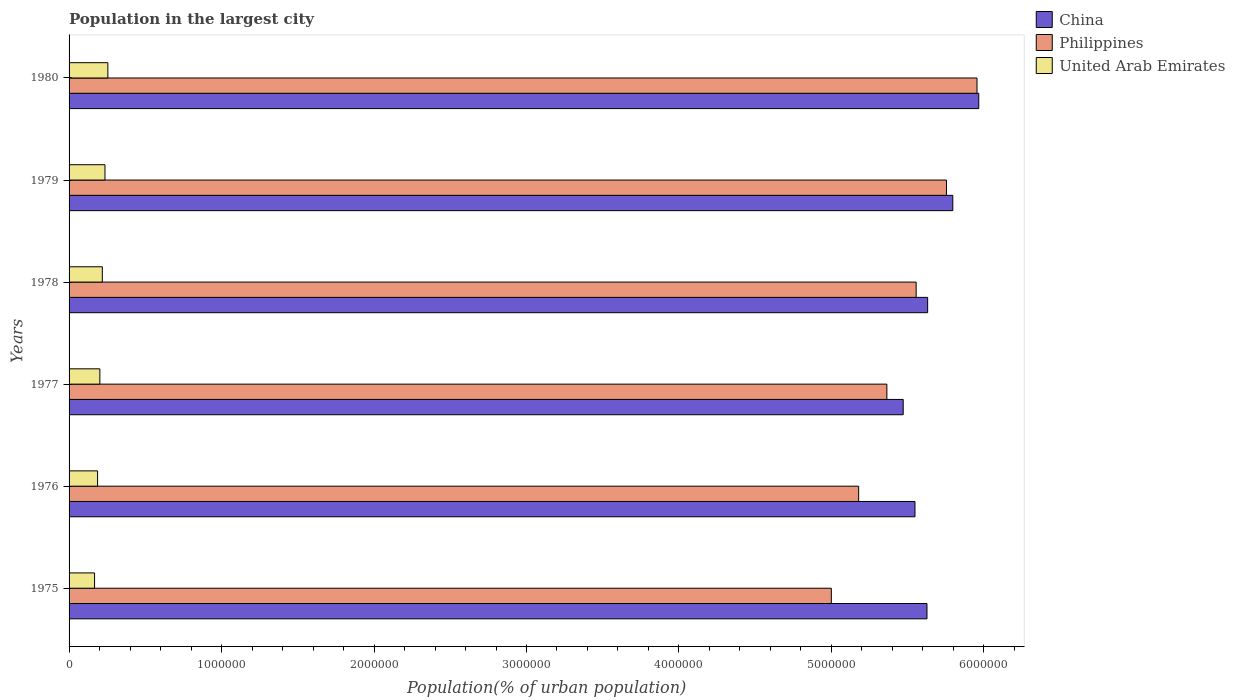How many different coloured bars are there?
Provide a succinct answer. 3. What is the label of the 2nd group of bars from the top?
Your response must be concise. 1979. What is the population in the largest city in Philippines in 1979?
Keep it short and to the point. 5.75e+06. Across all years, what is the maximum population in the largest city in Philippines?
Your response must be concise. 5.95e+06. Across all years, what is the minimum population in the largest city in China?
Your response must be concise. 5.47e+06. In which year was the population in the largest city in China maximum?
Make the answer very short. 1980. In which year was the population in the largest city in China minimum?
Keep it short and to the point. 1977. What is the total population in the largest city in Philippines in the graph?
Your answer should be very brief. 3.28e+07. What is the difference between the population in the largest city in China in 1976 and that in 1978?
Keep it short and to the point. -8.30e+04. What is the difference between the population in the largest city in Philippines in 1978 and the population in the largest city in China in 1977?
Your answer should be very brief. 8.50e+04. What is the average population in the largest city in United Arab Emirates per year?
Your response must be concise. 2.11e+05. In the year 1979, what is the difference between the population in the largest city in Philippines and population in the largest city in China?
Give a very brief answer. -4.16e+04. What is the ratio of the population in the largest city in Philippines in 1978 to that in 1980?
Provide a short and direct response. 0.93. Is the population in the largest city in China in 1977 less than that in 1978?
Keep it short and to the point. Yes. What is the difference between the highest and the second highest population in the largest city in United Arab Emirates?
Provide a short and direct response. 1.89e+04. What is the difference between the highest and the lowest population in the largest city in China?
Your answer should be compact. 4.96e+05. What does the 2nd bar from the top in 1978 represents?
Ensure brevity in your answer.  Philippines. What does the 1st bar from the bottom in 1975 represents?
Ensure brevity in your answer.  China. Is it the case that in every year, the sum of the population in the largest city in United Arab Emirates and population in the largest city in China is greater than the population in the largest city in Philippines?
Ensure brevity in your answer.  Yes. Are all the bars in the graph horizontal?
Give a very brief answer. Yes. How many years are there in the graph?
Provide a succinct answer. 6. Does the graph contain any zero values?
Keep it short and to the point. No. Does the graph contain grids?
Give a very brief answer. No. Where does the legend appear in the graph?
Offer a very short reply. Top right. What is the title of the graph?
Ensure brevity in your answer.  Population in the largest city. Does "Costa Rica" appear as one of the legend labels in the graph?
Ensure brevity in your answer.  No. What is the label or title of the X-axis?
Your answer should be compact. Population(% of urban population). What is the Population(% of urban population) in China in 1975?
Keep it short and to the point. 5.63e+06. What is the Population(% of urban population) in Philippines in 1975?
Give a very brief answer. 5.00e+06. What is the Population(% of urban population) of United Arab Emirates in 1975?
Your answer should be compact. 1.67e+05. What is the Population(% of urban population) of China in 1976?
Keep it short and to the point. 5.55e+06. What is the Population(% of urban population) in Philippines in 1976?
Offer a terse response. 5.18e+06. What is the Population(% of urban population) in United Arab Emirates in 1976?
Provide a short and direct response. 1.87e+05. What is the Population(% of urban population) in China in 1977?
Keep it short and to the point. 5.47e+06. What is the Population(% of urban population) in Philippines in 1977?
Your answer should be very brief. 5.36e+06. What is the Population(% of urban population) of United Arab Emirates in 1977?
Provide a succinct answer. 2.02e+05. What is the Population(% of urban population) in China in 1978?
Ensure brevity in your answer.  5.63e+06. What is the Population(% of urban population) in Philippines in 1978?
Ensure brevity in your answer.  5.56e+06. What is the Population(% of urban population) in United Arab Emirates in 1978?
Give a very brief answer. 2.18e+05. What is the Population(% of urban population) in China in 1979?
Give a very brief answer. 5.80e+06. What is the Population(% of urban population) of Philippines in 1979?
Offer a terse response. 5.75e+06. What is the Population(% of urban population) of United Arab Emirates in 1979?
Keep it short and to the point. 2.36e+05. What is the Population(% of urban population) of China in 1980?
Your answer should be very brief. 5.97e+06. What is the Population(% of urban population) in Philippines in 1980?
Offer a terse response. 5.95e+06. What is the Population(% of urban population) in United Arab Emirates in 1980?
Make the answer very short. 2.54e+05. Across all years, what is the maximum Population(% of urban population) of China?
Your answer should be compact. 5.97e+06. Across all years, what is the maximum Population(% of urban population) of Philippines?
Ensure brevity in your answer.  5.95e+06. Across all years, what is the maximum Population(% of urban population) in United Arab Emirates?
Give a very brief answer. 2.54e+05. Across all years, what is the minimum Population(% of urban population) of China?
Give a very brief answer. 5.47e+06. Across all years, what is the minimum Population(% of urban population) of Philippines?
Provide a succinct answer. 5.00e+06. Across all years, what is the minimum Population(% of urban population) of United Arab Emirates?
Make the answer very short. 1.67e+05. What is the total Population(% of urban population) of China in the graph?
Provide a succinct answer. 3.40e+07. What is the total Population(% of urban population) in Philippines in the graph?
Offer a terse response. 3.28e+07. What is the total Population(% of urban population) of United Arab Emirates in the graph?
Provide a succinct answer. 1.26e+06. What is the difference between the Population(% of urban population) of China in 1975 and that in 1976?
Your answer should be compact. 7.87e+04. What is the difference between the Population(% of urban population) in Philippines in 1975 and that in 1976?
Offer a terse response. -1.79e+05. What is the difference between the Population(% of urban population) of United Arab Emirates in 1975 and that in 1976?
Offer a terse response. -1.98e+04. What is the difference between the Population(% of urban population) in China in 1975 and that in 1977?
Offer a terse response. 1.56e+05. What is the difference between the Population(% of urban population) in Philippines in 1975 and that in 1977?
Make the answer very short. -3.64e+05. What is the difference between the Population(% of urban population) in United Arab Emirates in 1975 and that in 1977?
Your response must be concise. -3.47e+04. What is the difference between the Population(% of urban population) of China in 1975 and that in 1978?
Give a very brief answer. -4324. What is the difference between the Population(% of urban population) of Philippines in 1975 and that in 1978?
Give a very brief answer. -5.56e+05. What is the difference between the Population(% of urban population) of United Arab Emirates in 1975 and that in 1978?
Provide a succinct answer. -5.09e+04. What is the difference between the Population(% of urban population) in China in 1975 and that in 1979?
Your answer should be very brief. -1.69e+05. What is the difference between the Population(% of urban population) in Philippines in 1975 and that in 1979?
Ensure brevity in your answer.  -7.55e+05. What is the difference between the Population(% of urban population) of United Arab Emirates in 1975 and that in 1979?
Provide a short and direct response. -6.83e+04. What is the difference between the Population(% of urban population) of China in 1975 and that in 1980?
Ensure brevity in your answer.  -3.40e+05. What is the difference between the Population(% of urban population) in Philippines in 1975 and that in 1980?
Ensure brevity in your answer.  -9.55e+05. What is the difference between the Population(% of urban population) in United Arab Emirates in 1975 and that in 1980?
Offer a terse response. -8.72e+04. What is the difference between the Population(% of urban population) in China in 1976 and that in 1977?
Your answer should be very brief. 7.74e+04. What is the difference between the Population(% of urban population) in Philippines in 1976 and that in 1977?
Offer a very short reply. -1.85e+05. What is the difference between the Population(% of urban population) of United Arab Emirates in 1976 and that in 1977?
Make the answer very short. -1.49e+04. What is the difference between the Population(% of urban population) in China in 1976 and that in 1978?
Offer a very short reply. -8.30e+04. What is the difference between the Population(% of urban population) of Philippines in 1976 and that in 1978?
Offer a very short reply. -3.77e+05. What is the difference between the Population(% of urban population) in United Arab Emirates in 1976 and that in 1978?
Provide a succinct answer. -3.11e+04. What is the difference between the Population(% of urban population) in China in 1976 and that in 1979?
Ensure brevity in your answer.  -2.48e+05. What is the difference between the Population(% of urban population) in Philippines in 1976 and that in 1979?
Keep it short and to the point. -5.76e+05. What is the difference between the Population(% of urban population) of United Arab Emirates in 1976 and that in 1979?
Give a very brief answer. -4.85e+04. What is the difference between the Population(% of urban population) in China in 1976 and that in 1980?
Offer a terse response. -4.18e+05. What is the difference between the Population(% of urban population) in Philippines in 1976 and that in 1980?
Ensure brevity in your answer.  -7.76e+05. What is the difference between the Population(% of urban population) in United Arab Emirates in 1976 and that in 1980?
Offer a very short reply. -6.74e+04. What is the difference between the Population(% of urban population) of China in 1977 and that in 1978?
Ensure brevity in your answer.  -1.60e+05. What is the difference between the Population(% of urban population) of Philippines in 1977 and that in 1978?
Ensure brevity in your answer.  -1.92e+05. What is the difference between the Population(% of urban population) in United Arab Emirates in 1977 and that in 1978?
Offer a very short reply. -1.61e+04. What is the difference between the Population(% of urban population) in China in 1977 and that in 1979?
Your answer should be very brief. -3.25e+05. What is the difference between the Population(% of urban population) in Philippines in 1977 and that in 1979?
Offer a very short reply. -3.91e+05. What is the difference between the Population(% of urban population) in United Arab Emirates in 1977 and that in 1979?
Your answer should be compact. -3.36e+04. What is the difference between the Population(% of urban population) of China in 1977 and that in 1980?
Provide a short and direct response. -4.96e+05. What is the difference between the Population(% of urban population) of Philippines in 1977 and that in 1980?
Your response must be concise. -5.91e+05. What is the difference between the Population(% of urban population) of United Arab Emirates in 1977 and that in 1980?
Provide a succinct answer. -5.24e+04. What is the difference between the Population(% of urban population) of China in 1978 and that in 1979?
Provide a short and direct response. -1.65e+05. What is the difference between the Population(% of urban population) of Philippines in 1978 and that in 1979?
Offer a very short reply. -1.99e+05. What is the difference between the Population(% of urban population) of United Arab Emirates in 1978 and that in 1979?
Your answer should be very brief. -1.74e+04. What is the difference between the Population(% of urban population) in China in 1978 and that in 1980?
Make the answer very short. -3.35e+05. What is the difference between the Population(% of urban population) of Philippines in 1978 and that in 1980?
Keep it short and to the point. -3.99e+05. What is the difference between the Population(% of urban population) in United Arab Emirates in 1978 and that in 1980?
Keep it short and to the point. -3.63e+04. What is the difference between the Population(% of urban population) of China in 1979 and that in 1980?
Ensure brevity in your answer.  -1.70e+05. What is the difference between the Population(% of urban population) in Philippines in 1979 and that in 1980?
Provide a succinct answer. -2.00e+05. What is the difference between the Population(% of urban population) in United Arab Emirates in 1979 and that in 1980?
Provide a short and direct response. -1.89e+04. What is the difference between the Population(% of urban population) of China in 1975 and the Population(% of urban population) of Philippines in 1976?
Your answer should be compact. 4.48e+05. What is the difference between the Population(% of urban population) of China in 1975 and the Population(% of urban population) of United Arab Emirates in 1976?
Your answer should be very brief. 5.44e+06. What is the difference between the Population(% of urban population) of Philippines in 1975 and the Population(% of urban population) of United Arab Emirates in 1976?
Provide a short and direct response. 4.81e+06. What is the difference between the Population(% of urban population) in China in 1975 and the Population(% of urban population) in Philippines in 1977?
Your answer should be compact. 2.63e+05. What is the difference between the Population(% of urban population) of China in 1975 and the Population(% of urban population) of United Arab Emirates in 1977?
Ensure brevity in your answer.  5.42e+06. What is the difference between the Population(% of urban population) of Philippines in 1975 and the Population(% of urban population) of United Arab Emirates in 1977?
Offer a very short reply. 4.80e+06. What is the difference between the Population(% of urban population) of China in 1975 and the Population(% of urban population) of Philippines in 1978?
Your response must be concise. 7.10e+04. What is the difference between the Population(% of urban population) in China in 1975 and the Population(% of urban population) in United Arab Emirates in 1978?
Make the answer very short. 5.41e+06. What is the difference between the Population(% of urban population) in Philippines in 1975 and the Population(% of urban population) in United Arab Emirates in 1978?
Give a very brief answer. 4.78e+06. What is the difference between the Population(% of urban population) in China in 1975 and the Population(% of urban population) in Philippines in 1979?
Offer a terse response. -1.28e+05. What is the difference between the Population(% of urban population) of China in 1975 and the Population(% of urban population) of United Arab Emirates in 1979?
Your response must be concise. 5.39e+06. What is the difference between the Population(% of urban population) in Philippines in 1975 and the Population(% of urban population) in United Arab Emirates in 1979?
Your answer should be very brief. 4.76e+06. What is the difference between the Population(% of urban population) in China in 1975 and the Population(% of urban population) in Philippines in 1980?
Your answer should be very brief. -3.28e+05. What is the difference between the Population(% of urban population) in China in 1975 and the Population(% of urban population) in United Arab Emirates in 1980?
Your answer should be compact. 5.37e+06. What is the difference between the Population(% of urban population) of Philippines in 1975 and the Population(% of urban population) of United Arab Emirates in 1980?
Offer a terse response. 4.74e+06. What is the difference between the Population(% of urban population) of China in 1976 and the Population(% of urban population) of Philippines in 1977?
Give a very brief answer. 1.84e+05. What is the difference between the Population(% of urban population) in China in 1976 and the Population(% of urban population) in United Arab Emirates in 1977?
Your response must be concise. 5.35e+06. What is the difference between the Population(% of urban population) in Philippines in 1976 and the Population(% of urban population) in United Arab Emirates in 1977?
Your answer should be very brief. 4.98e+06. What is the difference between the Population(% of urban population) in China in 1976 and the Population(% of urban population) in Philippines in 1978?
Provide a short and direct response. -7629. What is the difference between the Population(% of urban population) of China in 1976 and the Population(% of urban population) of United Arab Emirates in 1978?
Ensure brevity in your answer.  5.33e+06. What is the difference between the Population(% of urban population) in Philippines in 1976 and the Population(% of urban population) in United Arab Emirates in 1978?
Your answer should be very brief. 4.96e+06. What is the difference between the Population(% of urban population) of China in 1976 and the Population(% of urban population) of Philippines in 1979?
Offer a terse response. -2.06e+05. What is the difference between the Population(% of urban population) in China in 1976 and the Population(% of urban population) in United Arab Emirates in 1979?
Provide a short and direct response. 5.31e+06. What is the difference between the Population(% of urban population) in Philippines in 1976 and the Population(% of urban population) in United Arab Emirates in 1979?
Provide a succinct answer. 4.94e+06. What is the difference between the Population(% of urban population) of China in 1976 and the Population(% of urban population) of Philippines in 1980?
Give a very brief answer. -4.07e+05. What is the difference between the Population(% of urban population) in China in 1976 and the Population(% of urban population) in United Arab Emirates in 1980?
Ensure brevity in your answer.  5.29e+06. What is the difference between the Population(% of urban population) of Philippines in 1976 and the Population(% of urban population) of United Arab Emirates in 1980?
Make the answer very short. 4.92e+06. What is the difference between the Population(% of urban population) in China in 1977 and the Population(% of urban population) in Philippines in 1978?
Keep it short and to the point. -8.50e+04. What is the difference between the Population(% of urban population) in China in 1977 and the Population(% of urban population) in United Arab Emirates in 1978?
Provide a short and direct response. 5.25e+06. What is the difference between the Population(% of urban population) of Philippines in 1977 and the Population(% of urban population) of United Arab Emirates in 1978?
Your response must be concise. 5.15e+06. What is the difference between the Population(% of urban population) in China in 1977 and the Population(% of urban population) in Philippines in 1979?
Offer a terse response. -2.84e+05. What is the difference between the Population(% of urban population) in China in 1977 and the Population(% of urban population) in United Arab Emirates in 1979?
Your answer should be very brief. 5.24e+06. What is the difference between the Population(% of urban population) in Philippines in 1977 and the Population(% of urban population) in United Arab Emirates in 1979?
Offer a very short reply. 5.13e+06. What is the difference between the Population(% of urban population) in China in 1977 and the Population(% of urban population) in Philippines in 1980?
Provide a succinct answer. -4.84e+05. What is the difference between the Population(% of urban population) of China in 1977 and the Population(% of urban population) of United Arab Emirates in 1980?
Provide a short and direct response. 5.22e+06. What is the difference between the Population(% of urban population) of Philippines in 1977 and the Population(% of urban population) of United Arab Emirates in 1980?
Offer a very short reply. 5.11e+06. What is the difference between the Population(% of urban population) in China in 1978 and the Population(% of urban population) in Philippines in 1979?
Give a very brief answer. -1.23e+05. What is the difference between the Population(% of urban population) in China in 1978 and the Population(% of urban population) in United Arab Emirates in 1979?
Give a very brief answer. 5.40e+06. What is the difference between the Population(% of urban population) of Philippines in 1978 and the Population(% of urban population) of United Arab Emirates in 1979?
Your response must be concise. 5.32e+06. What is the difference between the Population(% of urban population) in China in 1978 and the Population(% of urban population) in Philippines in 1980?
Your response must be concise. -3.24e+05. What is the difference between the Population(% of urban population) in China in 1978 and the Population(% of urban population) in United Arab Emirates in 1980?
Provide a succinct answer. 5.38e+06. What is the difference between the Population(% of urban population) in Philippines in 1978 and the Population(% of urban population) in United Arab Emirates in 1980?
Make the answer very short. 5.30e+06. What is the difference between the Population(% of urban population) of China in 1979 and the Population(% of urban population) of Philippines in 1980?
Offer a terse response. -1.59e+05. What is the difference between the Population(% of urban population) in China in 1979 and the Population(% of urban population) in United Arab Emirates in 1980?
Keep it short and to the point. 5.54e+06. What is the difference between the Population(% of urban population) in Philippines in 1979 and the Population(% of urban population) in United Arab Emirates in 1980?
Provide a succinct answer. 5.50e+06. What is the average Population(% of urban population) of China per year?
Ensure brevity in your answer.  5.67e+06. What is the average Population(% of urban population) in Philippines per year?
Ensure brevity in your answer.  5.47e+06. What is the average Population(% of urban population) of United Arab Emirates per year?
Make the answer very short. 2.11e+05. In the year 1975, what is the difference between the Population(% of urban population) in China and Population(% of urban population) in Philippines?
Your response must be concise. 6.27e+05. In the year 1975, what is the difference between the Population(% of urban population) of China and Population(% of urban population) of United Arab Emirates?
Make the answer very short. 5.46e+06. In the year 1975, what is the difference between the Population(% of urban population) of Philippines and Population(% of urban population) of United Arab Emirates?
Ensure brevity in your answer.  4.83e+06. In the year 1976, what is the difference between the Population(% of urban population) of China and Population(% of urban population) of Philippines?
Your response must be concise. 3.69e+05. In the year 1976, what is the difference between the Population(% of urban population) in China and Population(% of urban population) in United Arab Emirates?
Provide a short and direct response. 5.36e+06. In the year 1976, what is the difference between the Population(% of urban population) in Philippines and Population(% of urban population) in United Arab Emirates?
Ensure brevity in your answer.  4.99e+06. In the year 1977, what is the difference between the Population(% of urban population) in China and Population(% of urban population) in Philippines?
Provide a succinct answer. 1.07e+05. In the year 1977, what is the difference between the Population(% of urban population) in China and Population(% of urban population) in United Arab Emirates?
Keep it short and to the point. 5.27e+06. In the year 1977, what is the difference between the Population(% of urban population) of Philippines and Population(% of urban population) of United Arab Emirates?
Make the answer very short. 5.16e+06. In the year 1978, what is the difference between the Population(% of urban population) in China and Population(% of urban population) in Philippines?
Make the answer very short. 7.54e+04. In the year 1978, what is the difference between the Population(% of urban population) in China and Population(% of urban population) in United Arab Emirates?
Provide a succinct answer. 5.41e+06. In the year 1978, what is the difference between the Population(% of urban population) in Philippines and Population(% of urban population) in United Arab Emirates?
Offer a terse response. 5.34e+06. In the year 1979, what is the difference between the Population(% of urban population) of China and Population(% of urban population) of Philippines?
Keep it short and to the point. 4.16e+04. In the year 1979, what is the difference between the Population(% of urban population) of China and Population(% of urban population) of United Arab Emirates?
Ensure brevity in your answer.  5.56e+06. In the year 1979, what is the difference between the Population(% of urban population) of Philippines and Population(% of urban population) of United Arab Emirates?
Offer a terse response. 5.52e+06. In the year 1980, what is the difference between the Population(% of urban population) of China and Population(% of urban population) of Philippines?
Ensure brevity in your answer.  1.15e+04. In the year 1980, what is the difference between the Population(% of urban population) in China and Population(% of urban population) in United Arab Emirates?
Provide a short and direct response. 5.71e+06. In the year 1980, what is the difference between the Population(% of urban population) of Philippines and Population(% of urban population) of United Arab Emirates?
Your answer should be very brief. 5.70e+06. What is the ratio of the Population(% of urban population) of China in 1975 to that in 1976?
Provide a succinct answer. 1.01. What is the ratio of the Population(% of urban population) of Philippines in 1975 to that in 1976?
Your response must be concise. 0.97. What is the ratio of the Population(% of urban population) of United Arab Emirates in 1975 to that in 1976?
Provide a succinct answer. 0.89. What is the ratio of the Population(% of urban population) of China in 1975 to that in 1977?
Make the answer very short. 1.03. What is the ratio of the Population(% of urban population) of Philippines in 1975 to that in 1977?
Provide a short and direct response. 0.93. What is the ratio of the Population(% of urban population) in United Arab Emirates in 1975 to that in 1977?
Your answer should be compact. 0.83. What is the ratio of the Population(% of urban population) in China in 1975 to that in 1978?
Provide a succinct answer. 1. What is the ratio of the Population(% of urban population) in Philippines in 1975 to that in 1978?
Offer a very short reply. 0.9. What is the ratio of the Population(% of urban population) of United Arab Emirates in 1975 to that in 1978?
Your answer should be compact. 0.77. What is the ratio of the Population(% of urban population) of China in 1975 to that in 1979?
Offer a terse response. 0.97. What is the ratio of the Population(% of urban population) in Philippines in 1975 to that in 1979?
Ensure brevity in your answer.  0.87. What is the ratio of the Population(% of urban population) in United Arab Emirates in 1975 to that in 1979?
Provide a short and direct response. 0.71. What is the ratio of the Population(% of urban population) in China in 1975 to that in 1980?
Ensure brevity in your answer.  0.94. What is the ratio of the Population(% of urban population) in Philippines in 1975 to that in 1980?
Your response must be concise. 0.84. What is the ratio of the Population(% of urban population) in United Arab Emirates in 1975 to that in 1980?
Keep it short and to the point. 0.66. What is the ratio of the Population(% of urban population) of China in 1976 to that in 1977?
Offer a very short reply. 1.01. What is the ratio of the Population(% of urban population) in Philippines in 1976 to that in 1977?
Make the answer very short. 0.97. What is the ratio of the Population(% of urban population) of United Arab Emirates in 1976 to that in 1977?
Offer a very short reply. 0.93. What is the ratio of the Population(% of urban population) in Philippines in 1976 to that in 1978?
Give a very brief answer. 0.93. What is the ratio of the Population(% of urban population) of United Arab Emirates in 1976 to that in 1978?
Give a very brief answer. 0.86. What is the ratio of the Population(% of urban population) in China in 1976 to that in 1979?
Offer a very short reply. 0.96. What is the ratio of the Population(% of urban population) in Philippines in 1976 to that in 1979?
Ensure brevity in your answer.  0.9. What is the ratio of the Population(% of urban population) of United Arab Emirates in 1976 to that in 1979?
Provide a short and direct response. 0.79. What is the ratio of the Population(% of urban population) of China in 1976 to that in 1980?
Provide a succinct answer. 0.93. What is the ratio of the Population(% of urban population) in Philippines in 1976 to that in 1980?
Your answer should be very brief. 0.87. What is the ratio of the Population(% of urban population) of United Arab Emirates in 1976 to that in 1980?
Make the answer very short. 0.74. What is the ratio of the Population(% of urban population) of China in 1977 to that in 1978?
Offer a terse response. 0.97. What is the ratio of the Population(% of urban population) of Philippines in 1977 to that in 1978?
Offer a terse response. 0.97. What is the ratio of the Population(% of urban population) in United Arab Emirates in 1977 to that in 1978?
Offer a terse response. 0.93. What is the ratio of the Population(% of urban population) in China in 1977 to that in 1979?
Your answer should be compact. 0.94. What is the ratio of the Population(% of urban population) in Philippines in 1977 to that in 1979?
Ensure brevity in your answer.  0.93. What is the ratio of the Population(% of urban population) of United Arab Emirates in 1977 to that in 1979?
Provide a succinct answer. 0.86. What is the ratio of the Population(% of urban population) of China in 1977 to that in 1980?
Provide a short and direct response. 0.92. What is the ratio of the Population(% of urban population) of Philippines in 1977 to that in 1980?
Offer a very short reply. 0.9. What is the ratio of the Population(% of urban population) in United Arab Emirates in 1977 to that in 1980?
Offer a very short reply. 0.79. What is the ratio of the Population(% of urban population) of China in 1978 to that in 1979?
Keep it short and to the point. 0.97. What is the ratio of the Population(% of urban population) in Philippines in 1978 to that in 1979?
Ensure brevity in your answer.  0.97. What is the ratio of the Population(% of urban population) of United Arab Emirates in 1978 to that in 1979?
Your answer should be very brief. 0.93. What is the ratio of the Population(% of urban population) of China in 1978 to that in 1980?
Give a very brief answer. 0.94. What is the ratio of the Population(% of urban population) in Philippines in 1978 to that in 1980?
Your answer should be compact. 0.93. What is the ratio of the Population(% of urban population) in United Arab Emirates in 1978 to that in 1980?
Provide a short and direct response. 0.86. What is the ratio of the Population(% of urban population) in China in 1979 to that in 1980?
Keep it short and to the point. 0.97. What is the ratio of the Population(% of urban population) of Philippines in 1979 to that in 1980?
Make the answer very short. 0.97. What is the ratio of the Population(% of urban population) of United Arab Emirates in 1979 to that in 1980?
Offer a terse response. 0.93. What is the difference between the highest and the second highest Population(% of urban population) of China?
Offer a very short reply. 1.70e+05. What is the difference between the highest and the second highest Population(% of urban population) in Philippines?
Your response must be concise. 2.00e+05. What is the difference between the highest and the second highest Population(% of urban population) of United Arab Emirates?
Your answer should be compact. 1.89e+04. What is the difference between the highest and the lowest Population(% of urban population) in China?
Give a very brief answer. 4.96e+05. What is the difference between the highest and the lowest Population(% of urban population) in Philippines?
Give a very brief answer. 9.55e+05. What is the difference between the highest and the lowest Population(% of urban population) in United Arab Emirates?
Your answer should be very brief. 8.72e+04. 